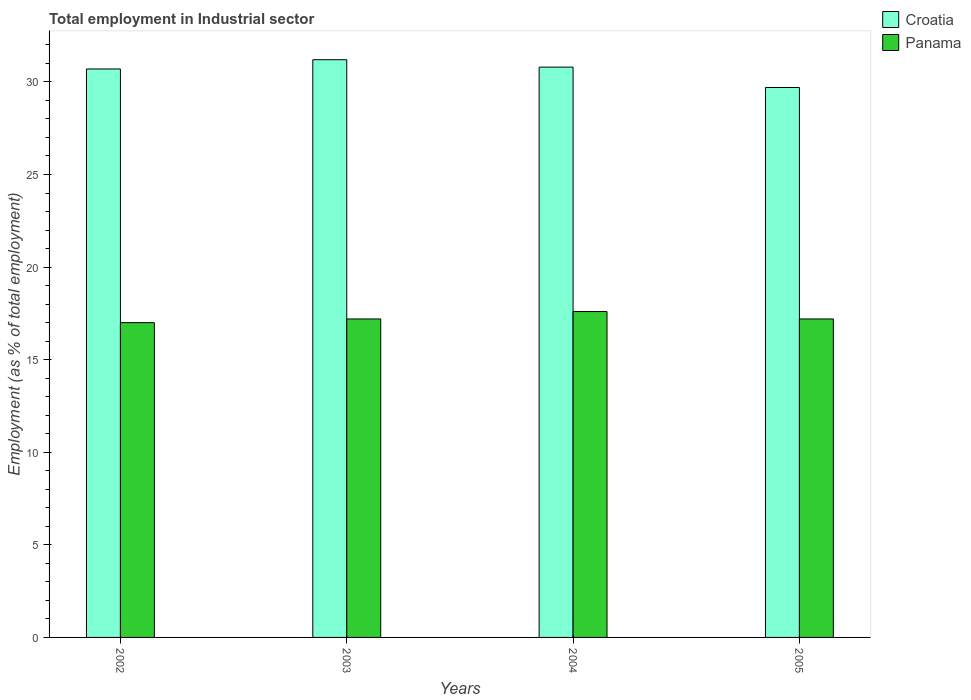How many different coloured bars are there?
Offer a terse response. 2. Are the number of bars per tick equal to the number of legend labels?
Ensure brevity in your answer.  Yes. Are the number of bars on each tick of the X-axis equal?
Your response must be concise. Yes. How many bars are there on the 1st tick from the left?
Provide a succinct answer. 2. How many bars are there on the 1st tick from the right?
Make the answer very short. 2. What is the label of the 2nd group of bars from the left?
Your response must be concise. 2003. In how many cases, is the number of bars for a given year not equal to the number of legend labels?
Your answer should be very brief. 0. Across all years, what is the maximum employment in industrial sector in Panama?
Provide a succinct answer. 17.6. Across all years, what is the minimum employment in industrial sector in Croatia?
Your answer should be compact. 29.7. What is the total employment in industrial sector in Croatia in the graph?
Provide a short and direct response. 122.4. What is the difference between the employment in industrial sector in Panama in 2002 and that in 2005?
Your answer should be very brief. -0.2. What is the difference between the employment in industrial sector in Panama in 2003 and the employment in industrial sector in Croatia in 2002?
Make the answer very short. -13.5. What is the average employment in industrial sector in Croatia per year?
Your response must be concise. 30.6. In the year 2002, what is the difference between the employment in industrial sector in Panama and employment in industrial sector in Croatia?
Offer a very short reply. -13.7. In how many years, is the employment in industrial sector in Croatia greater than 2 %?
Make the answer very short. 4. Is the difference between the employment in industrial sector in Panama in 2003 and 2005 greater than the difference between the employment in industrial sector in Croatia in 2003 and 2005?
Provide a short and direct response. No. What is the difference between the highest and the second highest employment in industrial sector in Croatia?
Offer a terse response. 0.4. What is the difference between the highest and the lowest employment in industrial sector in Panama?
Offer a terse response. 0.6. Is the sum of the employment in industrial sector in Panama in 2002 and 2003 greater than the maximum employment in industrial sector in Croatia across all years?
Your response must be concise. Yes. What does the 2nd bar from the left in 2002 represents?
Your response must be concise. Panama. What does the 2nd bar from the right in 2004 represents?
Keep it short and to the point. Croatia. Are all the bars in the graph horizontal?
Keep it short and to the point. No. How many years are there in the graph?
Offer a very short reply. 4. What is the difference between two consecutive major ticks on the Y-axis?
Offer a very short reply. 5. How are the legend labels stacked?
Your answer should be very brief. Vertical. What is the title of the graph?
Provide a short and direct response. Total employment in Industrial sector. Does "Pakistan" appear as one of the legend labels in the graph?
Provide a succinct answer. No. What is the label or title of the Y-axis?
Provide a succinct answer. Employment (as % of total employment). What is the Employment (as % of total employment) in Croatia in 2002?
Your answer should be very brief. 30.7. What is the Employment (as % of total employment) of Croatia in 2003?
Offer a terse response. 31.2. What is the Employment (as % of total employment) in Panama in 2003?
Keep it short and to the point. 17.2. What is the Employment (as % of total employment) of Croatia in 2004?
Make the answer very short. 30.8. What is the Employment (as % of total employment) of Panama in 2004?
Your answer should be compact. 17.6. What is the Employment (as % of total employment) of Croatia in 2005?
Offer a terse response. 29.7. What is the Employment (as % of total employment) of Panama in 2005?
Keep it short and to the point. 17.2. Across all years, what is the maximum Employment (as % of total employment) of Croatia?
Your answer should be compact. 31.2. Across all years, what is the maximum Employment (as % of total employment) in Panama?
Offer a terse response. 17.6. Across all years, what is the minimum Employment (as % of total employment) in Croatia?
Your response must be concise. 29.7. Across all years, what is the minimum Employment (as % of total employment) in Panama?
Give a very brief answer. 17. What is the total Employment (as % of total employment) of Croatia in the graph?
Your response must be concise. 122.4. What is the difference between the Employment (as % of total employment) in Panama in 2002 and that in 2003?
Your answer should be compact. -0.2. What is the difference between the Employment (as % of total employment) in Croatia in 2002 and that in 2004?
Offer a very short reply. -0.1. What is the difference between the Employment (as % of total employment) in Panama in 2003 and that in 2005?
Provide a succinct answer. 0. What is the difference between the Employment (as % of total employment) in Croatia in 2004 and that in 2005?
Provide a succinct answer. 1.1. What is the difference between the Employment (as % of total employment) of Croatia in 2002 and the Employment (as % of total employment) of Panama in 2003?
Your response must be concise. 13.5. What is the difference between the Employment (as % of total employment) of Croatia in 2003 and the Employment (as % of total employment) of Panama in 2004?
Offer a very short reply. 13.6. What is the difference between the Employment (as % of total employment) in Croatia in 2004 and the Employment (as % of total employment) in Panama in 2005?
Your answer should be very brief. 13.6. What is the average Employment (as % of total employment) in Croatia per year?
Offer a very short reply. 30.6. What is the average Employment (as % of total employment) of Panama per year?
Offer a terse response. 17.25. In the year 2003, what is the difference between the Employment (as % of total employment) of Croatia and Employment (as % of total employment) of Panama?
Offer a very short reply. 14. In the year 2005, what is the difference between the Employment (as % of total employment) in Croatia and Employment (as % of total employment) in Panama?
Your response must be concise. 12.5. What is the ratio of the Employment (as % of total employment) of Panama in 2002 to that in 2003?
Make the answer very short. 0.99. What is the ratio of the Employment (as % of total employment) in Panama in 2002 to that in 2004?
Ensure brevity in your answer.  0.97. What is the ratio of the Employment (as % of total employment) of Croatia in 2002 to that in 2005?
Provide a succinct answer. 1.03. What is the ratio of the Employment (as % of total employment) in Panama in 2002 to that in 2005?
Keep it short and to the point. 0.99. What is the ratio of the Employment (as % of total employment) of Croatia in 2003 to that in 2004?
Your response must be concise. 1.01. What is the ratio of the Employment (as % of total employment) in Panama in 2003 to that in 2004?
Your response must be concise. 0.98. What is the ratio of the Employment (as % of total employment) in Croatia in 2003 to that in 2005?
Your response must be concise. 1.05. What is the ratio of the Employment (as % of total employment) of Panama in 2003 to that in 2005?
Offer a terse response. 1. What is the ratio of the Employment (as % of total employment) of Croatia in 2004 to that in 2005?
Your answer should be very brief. 1.04. What is the ratio of the Employment (as % of total employment) in Panama in 2004 to that in 2005?
Your answer should be very brief. 1.02. What is the difference between the highest and the second highest Employment (as % of total employment) of Croatia?
Your answer should be compact. 0.4. 